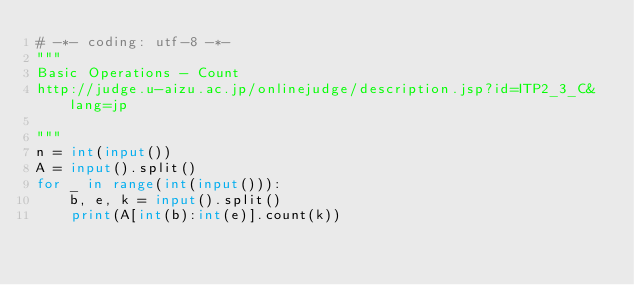Convert code to text. <code><loc_0><loc_0><loc_500><loc_500><_Python_># -*- coding: utf-8 -*-
"""
Basic Operations - Count
http://judge.u-aizu.ac.jp/onlinejudge/description.jsp?id=ITP2_3_C&lang=jp

"""
n = int(input())
A = input().split()
for _ in range(int(input())):
    b, e, k = input().split()
    print(A[int(b):int(e)].count(k))
    
</code> 